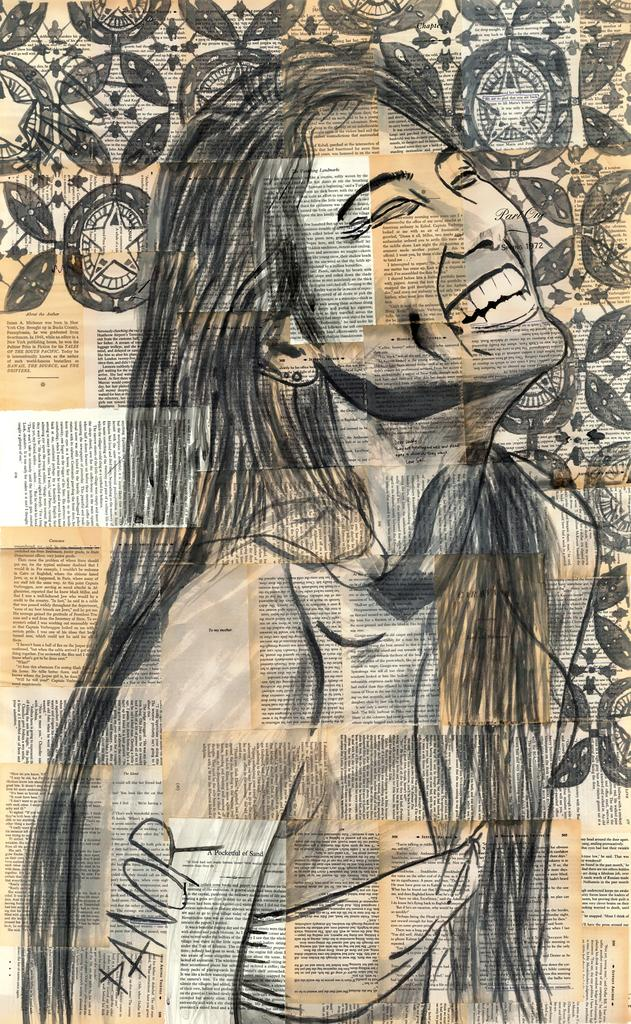<image>
Write a terse but informative summary of the picture. A sketch of a woman smiling with the name Danor on her arm. 